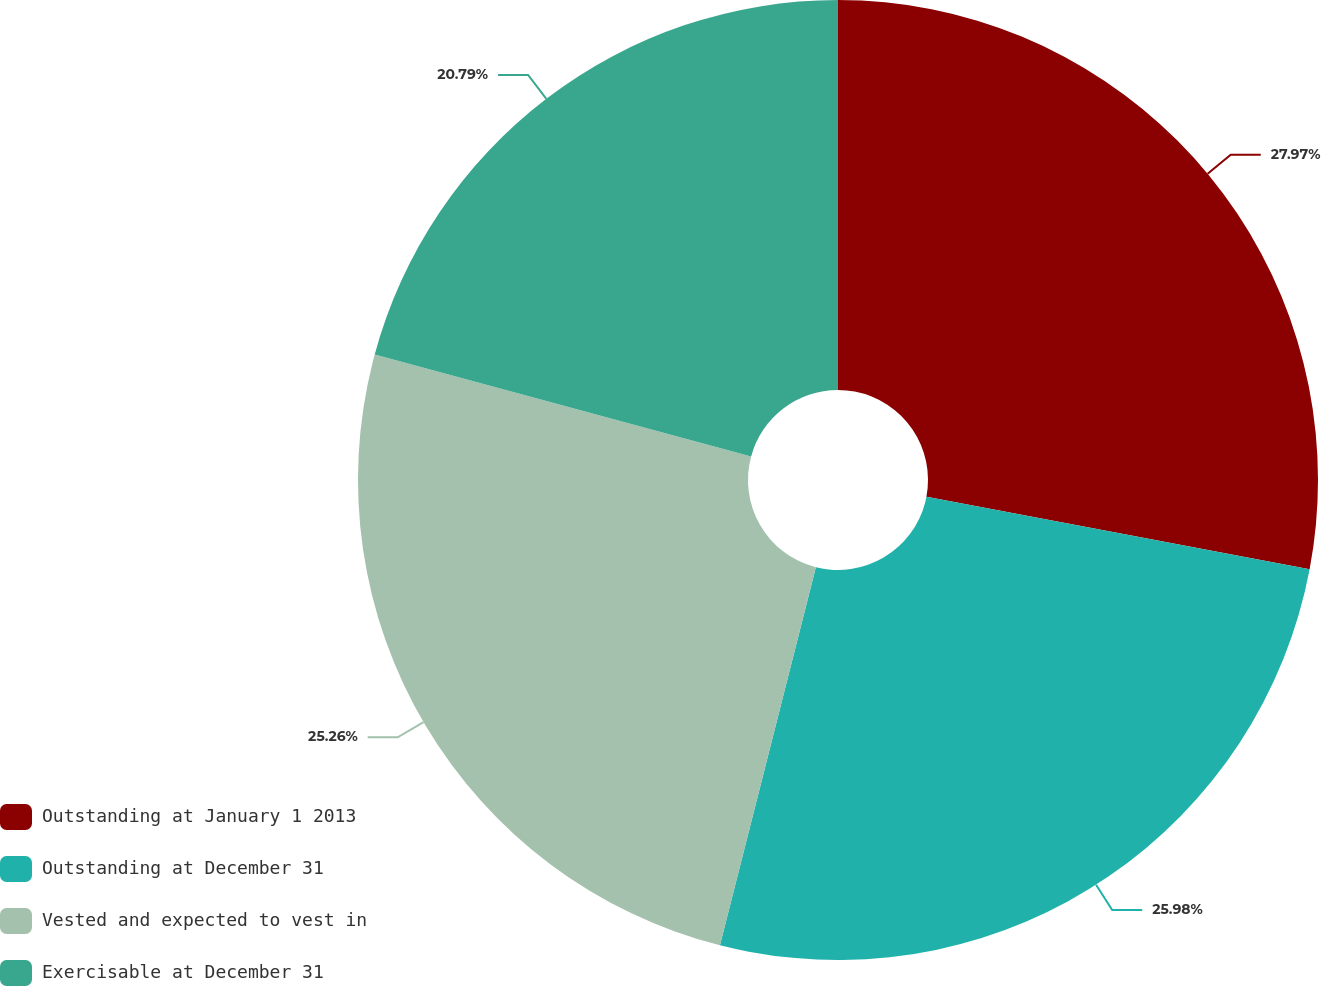Convert chart to OTSL. <chart><loc_0><loc_0><loc_500><loc_500><pie_chart><fcel>Outstanding at January 1 2013<fcel>Outstanding at December 31<fcel>Vested and expected to vest in<fcel>Exercisable at December 31<nl><fcel>27.98%<fcel>25.98%<fcel>25.26%<fcel>20.79%<nl></chart> 